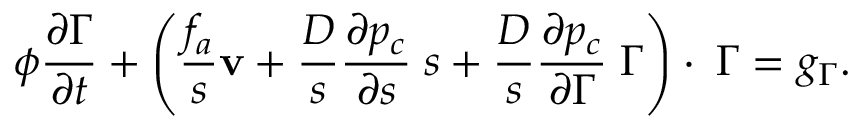<formula> <loc_0><loc_0><loc_500><loc_500>\phi \frac { \partial \Gamma } { \partial t } + \left ( \frac { f _ { a } } { s } { v } + \frac { D } { s } \frac { \partial p _ { c } } { \partial s } { \nabla } s + \frac { D } { s } \frac { \partial p _ { c } } { \partial \Gamma } { \nabla } \Gamma \right ) \cdot { \nabla } \Gamma = g _ { \Gamma } .</formula> 